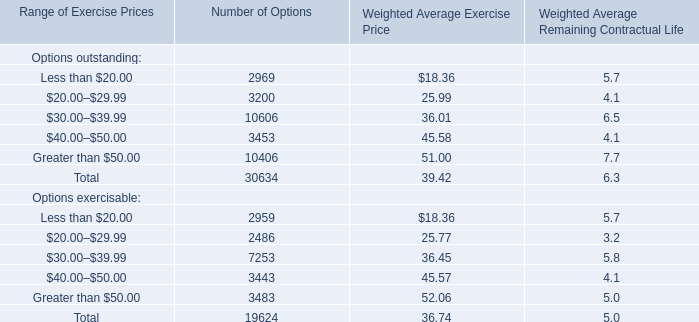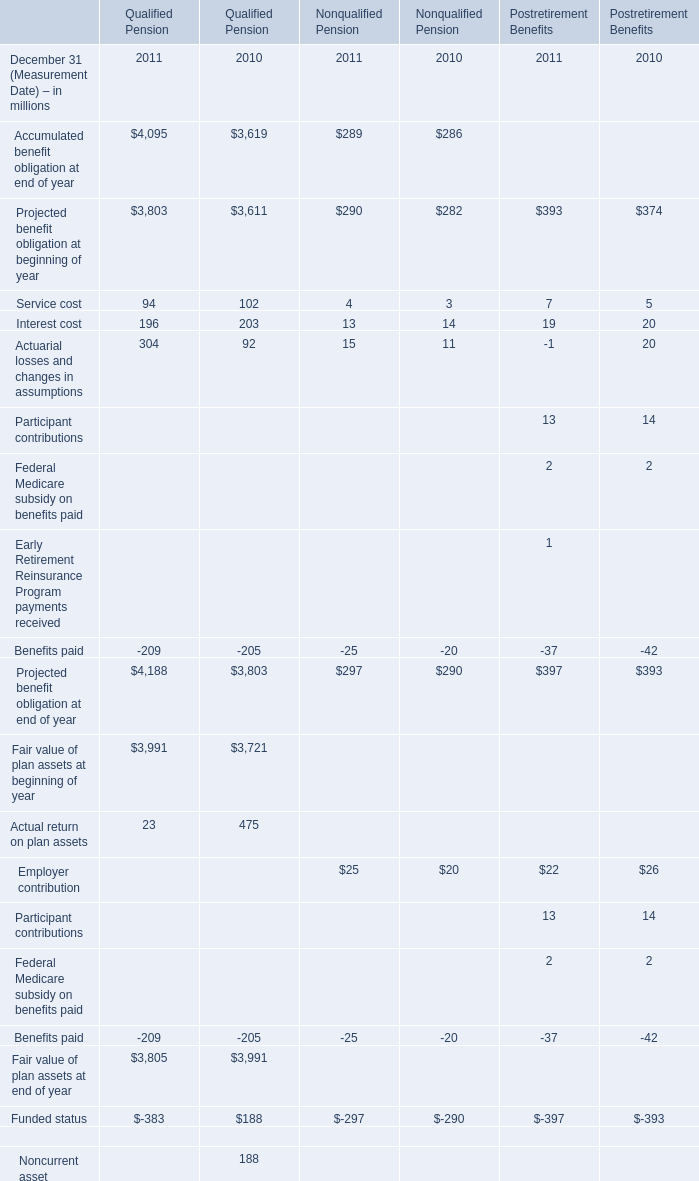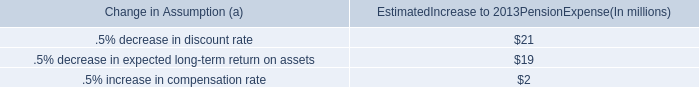What's the increasing rate of service cost in 2011 for qualified pension? (in %) 
Computations: ((94 - 102) / 102)
Answer: -0.07843. 